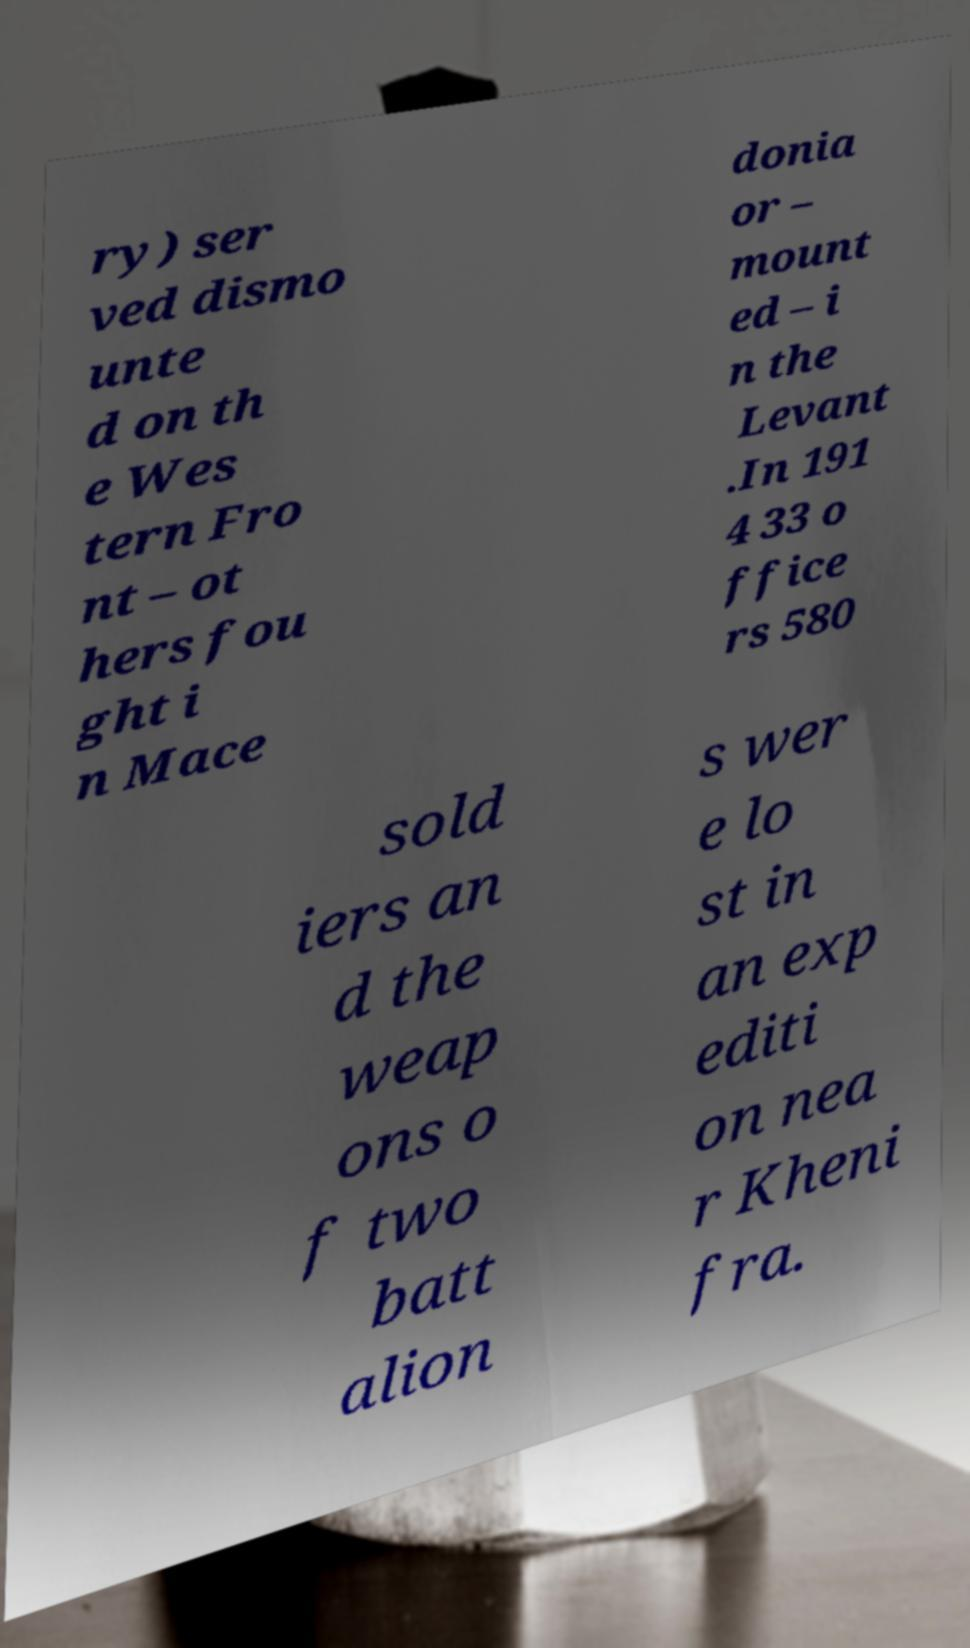Please identify and transcribe the text found in this image. ry) ser ved dismo unte d on th e Wes tern Fro nt – ot hers fou ght i n Mace donia or – mount ed – i n the Levant .In 191 4 33 o ffice rs 580 sold iers an d the weap ons o f two batt alion s wer e lo st in an exp editi on nea r Kheni fra. 